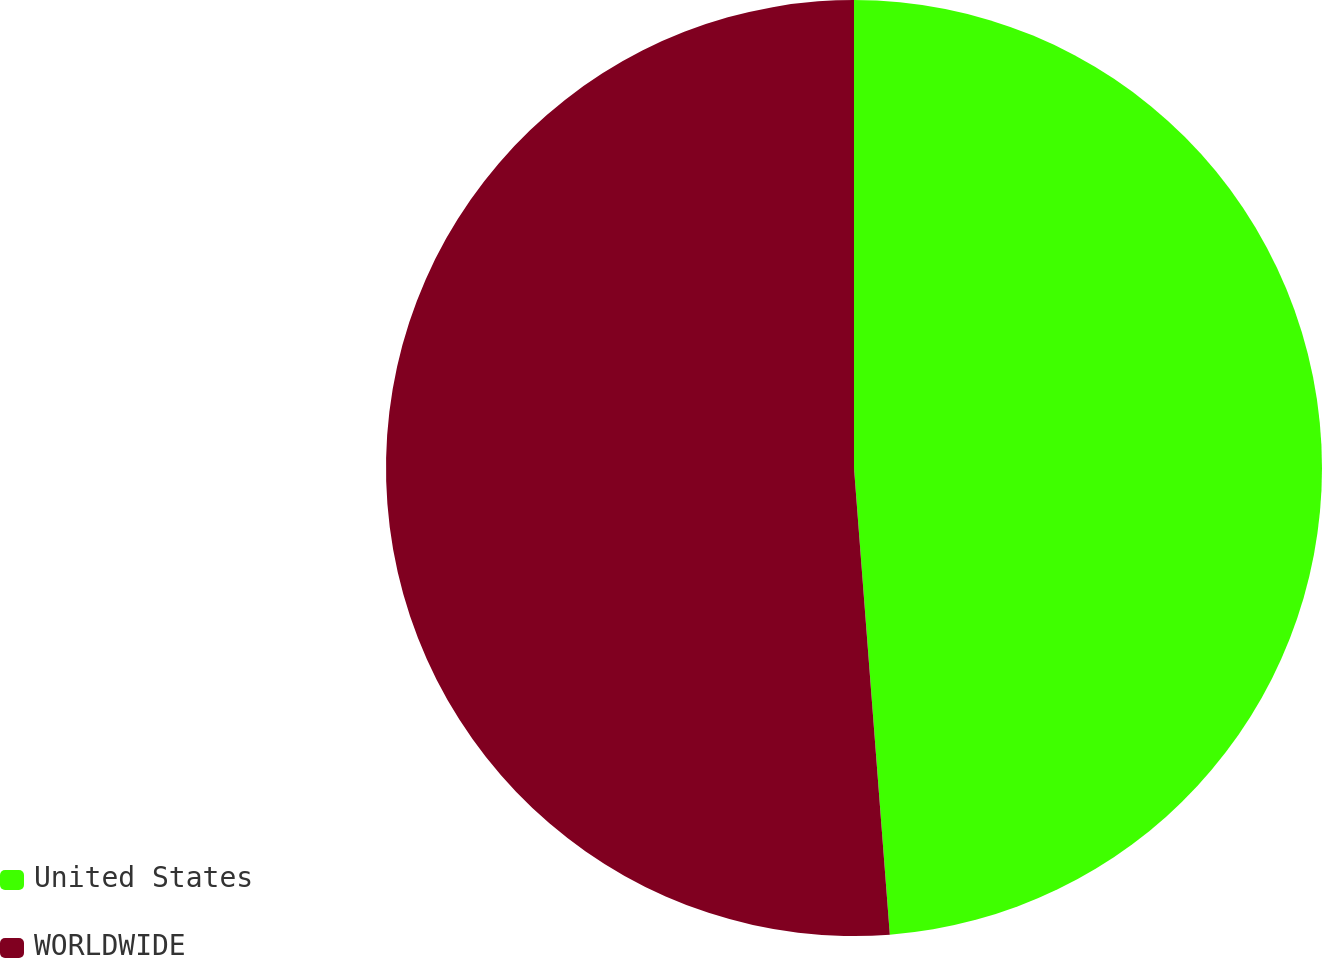<chart> <loc_0><loc_0><loc_500><loc_500><pie_chart><fcel>United States<fcel>WORLDWIDE<nl><fcel>48.78%<fcel>51.22%<nl></chart> 